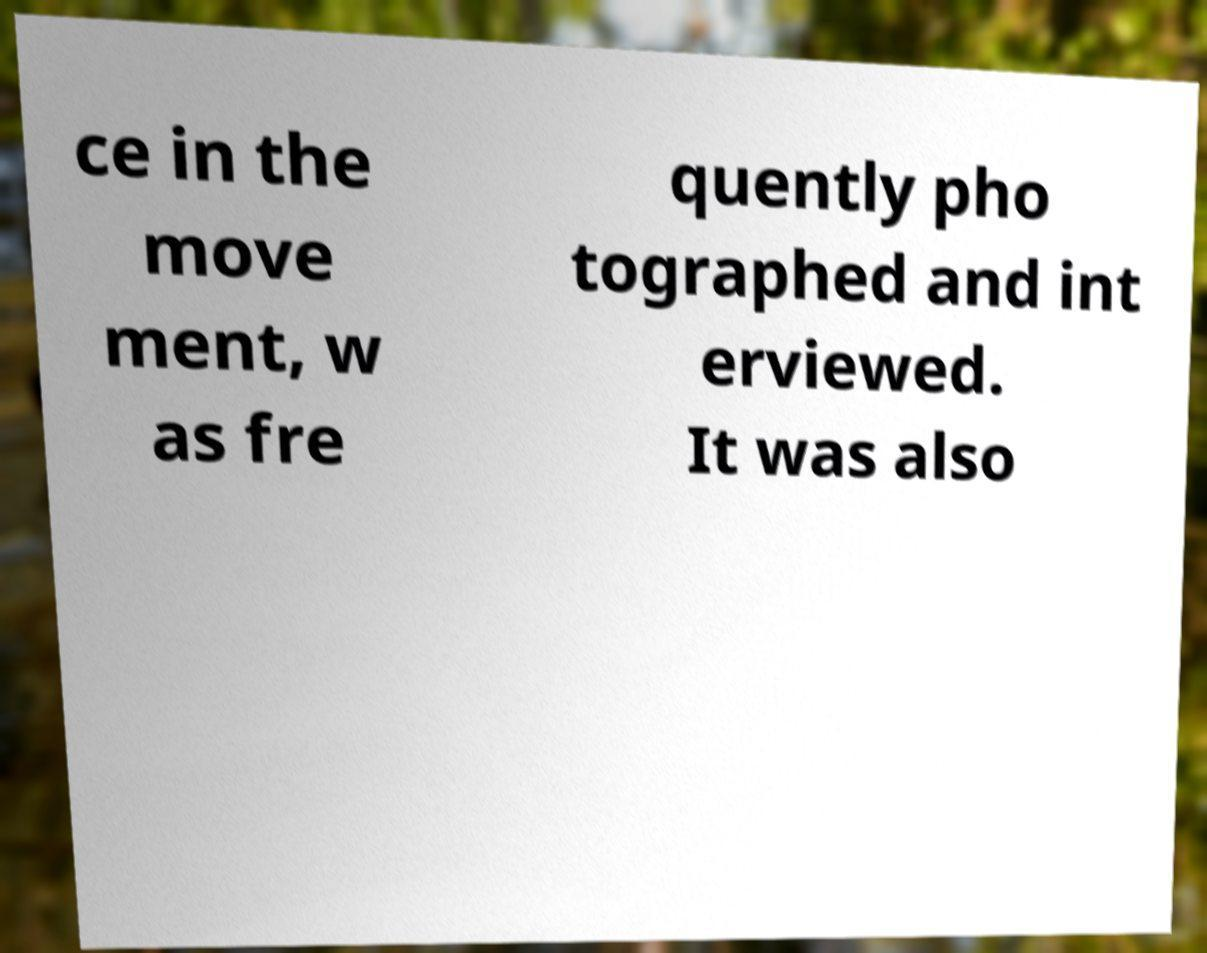What messages or text are displayed in this image? I need them in a readable, typed format. ce in the move ment, w as fre quently pho tographed and int erviewed. It was also 